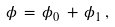Convert formula to latex. <formula><loc_0><loc_0><loc_500><loc_500>\phi \, = \, \phi _ { 0 } \, + \, \phi _ { 1 } \, ,</formula> 